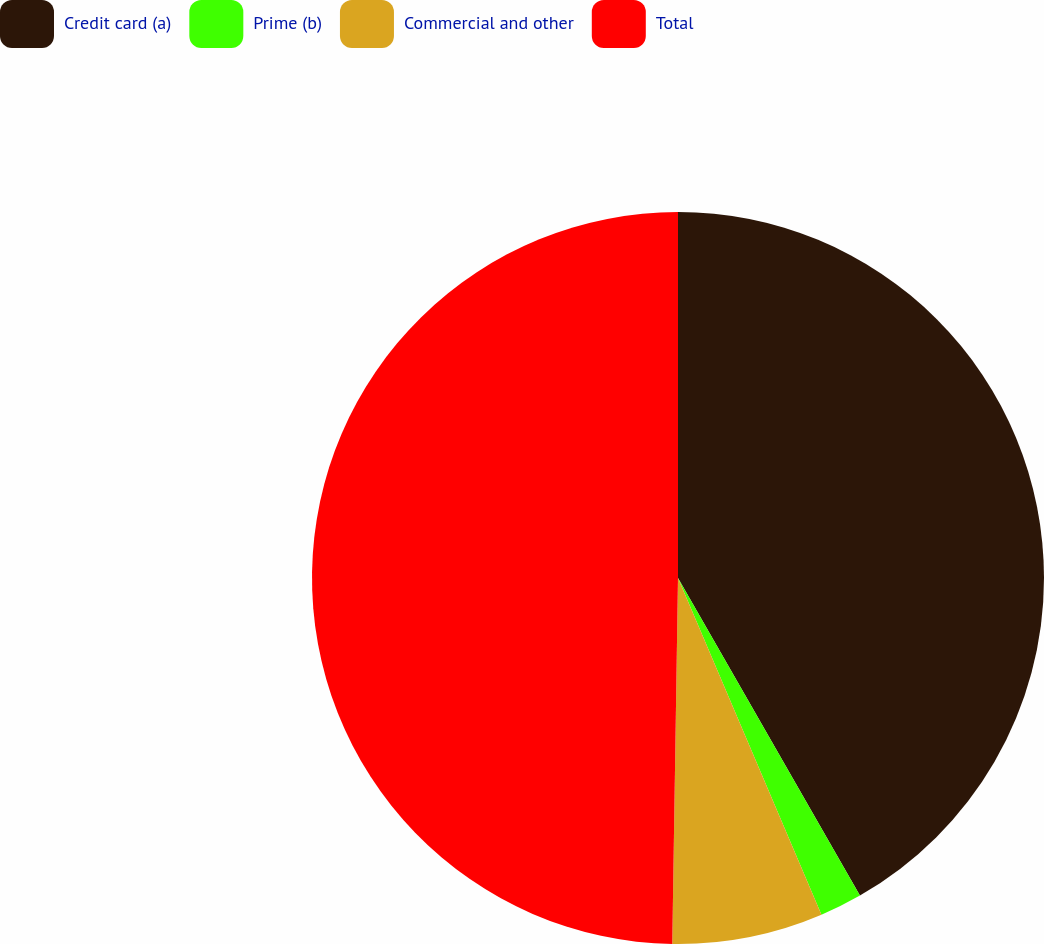<chart> <loc_0><loc_0><loc_500><loc_500><pie_chart><fcel>Credit card (a)<fcel>Prime (b)<fcel>Commercial and other<fcel>Total<nl><fcel>41.72%<fcel>1.87%<fcel>6.66%<fcel>49.75%<nl></chart> 